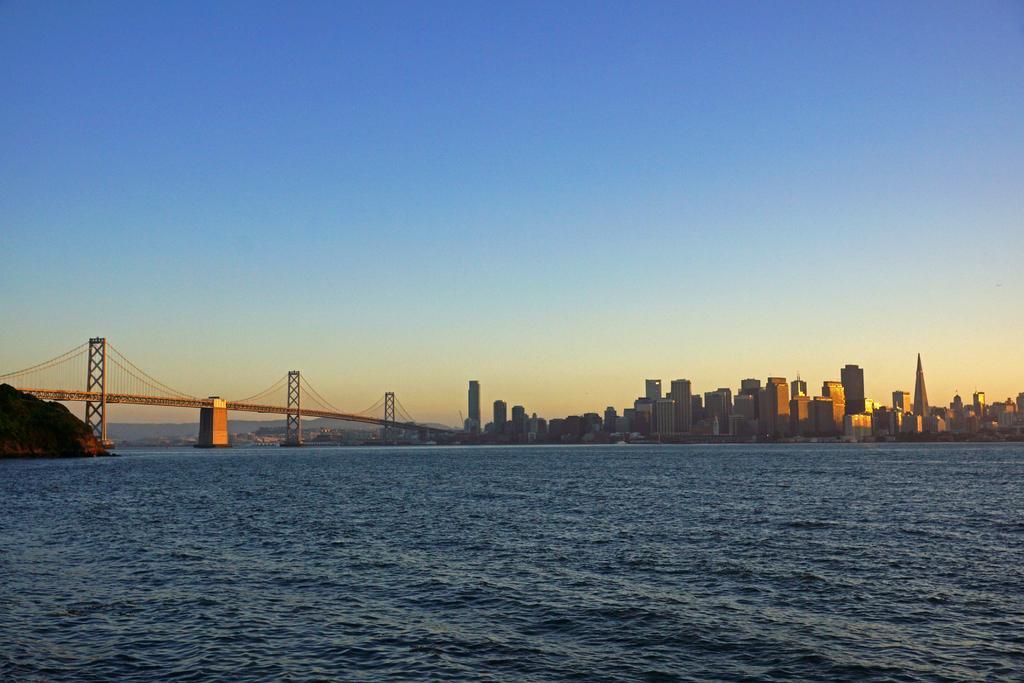Can you describe this image briefly? In this picture we can see buildings and skyscrapers. On the left there is a bridge. At the bottom we can see the water. In the background we can see mountains. At the top there is a sky. 